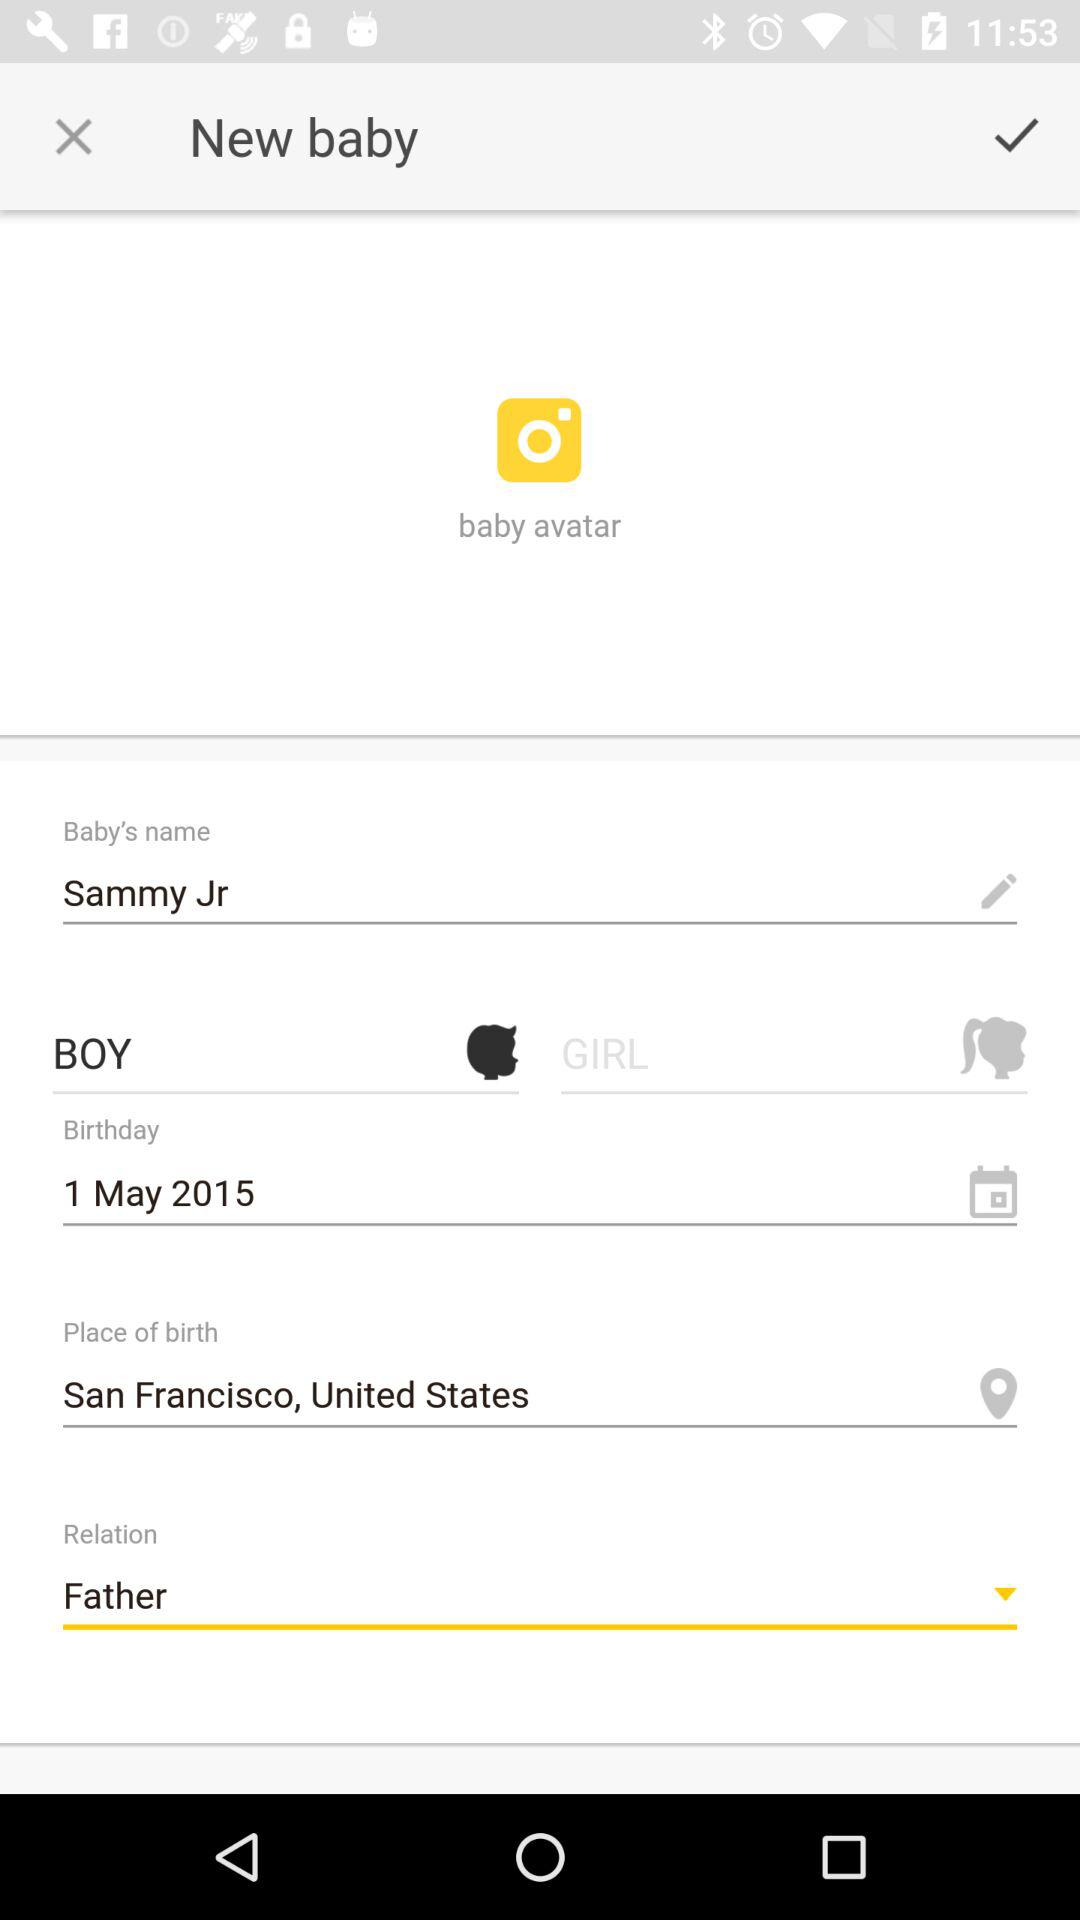Baby is born at which place? Baby is born in San Francisco, California, USA. 